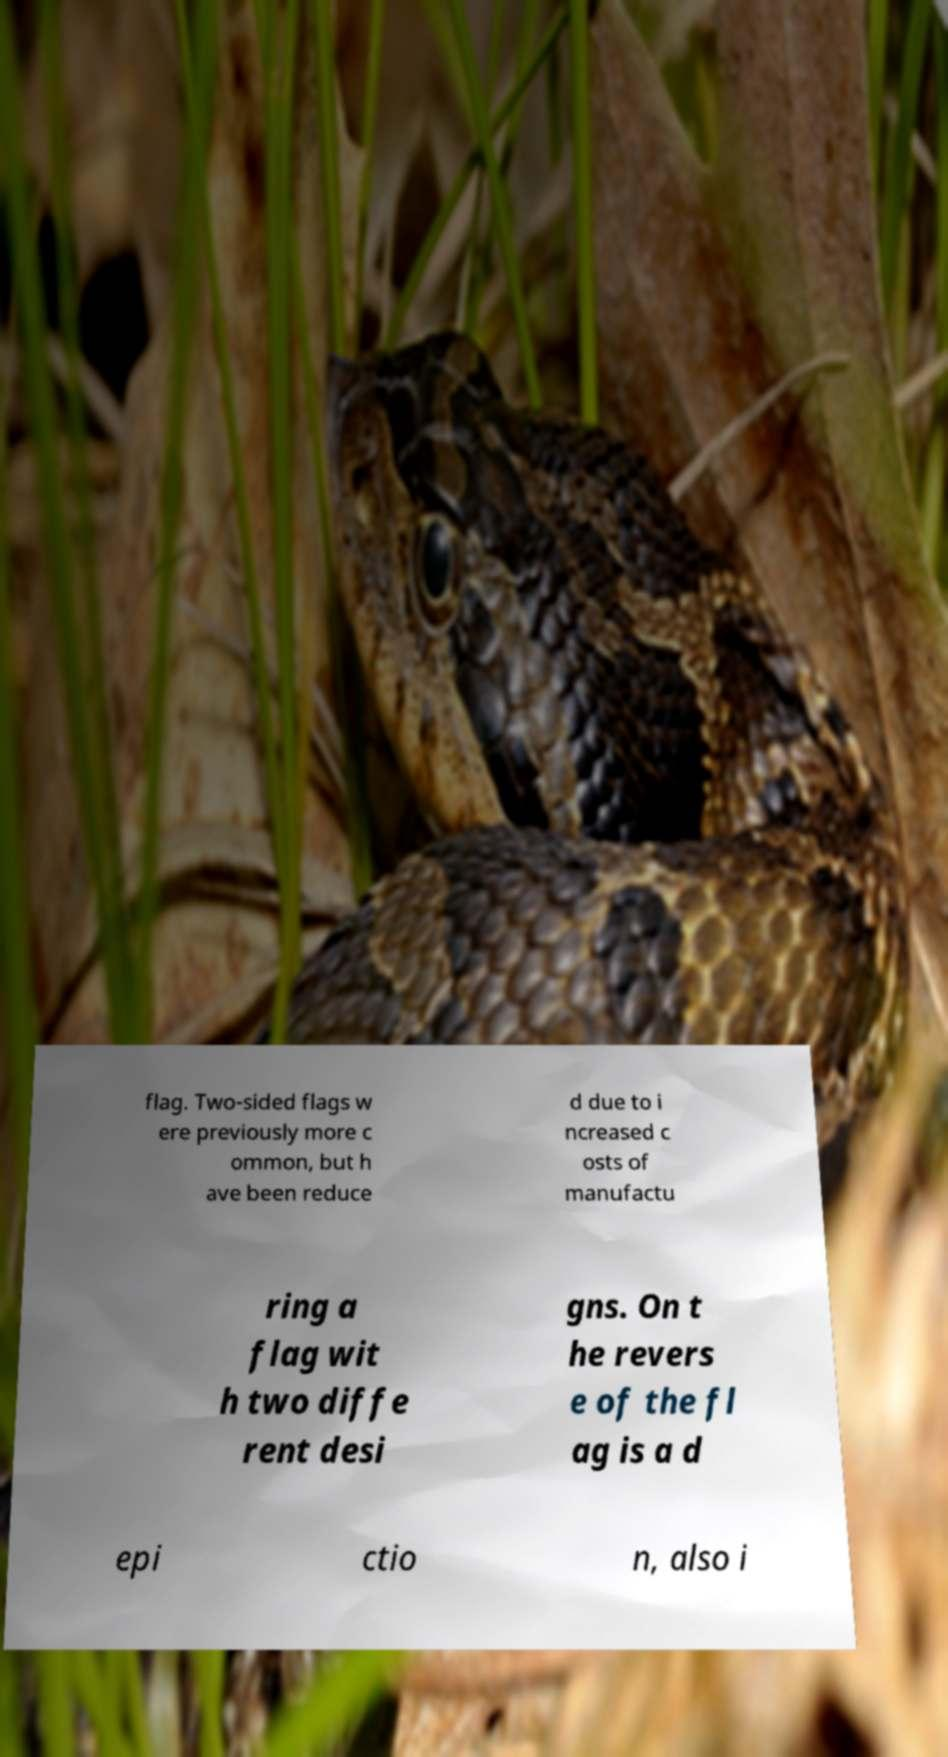Can you accurately transcribe the text from the provided image for me? flag. Two-sided flags w ere previously more c ommon, but h ave been reduce d due to i ncreased c osts of manufactu ring a flag wit h two diffe rent desi gns. On t he revers e of the fl ag is a d epi ctio n, also i 